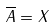Convert formula to latex. <formula><loc_0><loc_0><loc_500><loc_500>\overline { A } = X</formula> 